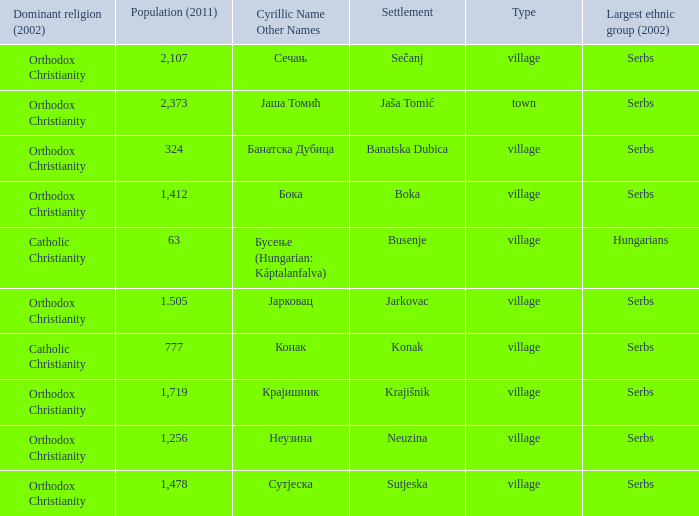The population is 2,107's dominant religion is? Orthodox Christianity. Could you help me parse every detail presented in this table? {'header': ['Dominant religion (2002)', 'Population (2011)', 'Cyrillic Name Other Names', 'Settlement', 'Type', 'Largest ethnic group (2002)'], 'rows': [['Orthodox Christianity', '2,107', 'Сечањ', 'Sečanj', 'village', 'Serbs'], ['Orthodox Christianity', '2,373', 'Јаша Томић', 'Jaša Tomić', 'town', 'Serbs'], ['Orthodox Christianity', '324', 'Банатска Дубица', 'Banatska Dubica', 'village', 'Serbs'], ['Orthodox Christianity', '1,412', 'Бока', 'Boka', 'village', 'Serbs'], ['Catholic Christianity', '63', 'Бусење (Hungarian: Káptalanfalva)', 'Busenje', 'village', 'Hungarians'], ['Orthodox Christianity', '1.505', 'Јарковац', 'Jarkovac', 'village', 'Serbs'], ['Catholic Christianity', '777', 'Конак', 'Konak', 'village', 'Serbs'], ['Orthodox Christianity', '1,719', 'Крајишник', 'Krajišnik', 'village', 'Serbs'], ['Orthodox Christianity', '1,256', 'Неузина', 'Neuzina', 'village', 'Serbs'], ['Orthodox Christianity', '1,478', 'Сутјеска', 'Sutjeska', 'village', 'Serbs']]} 